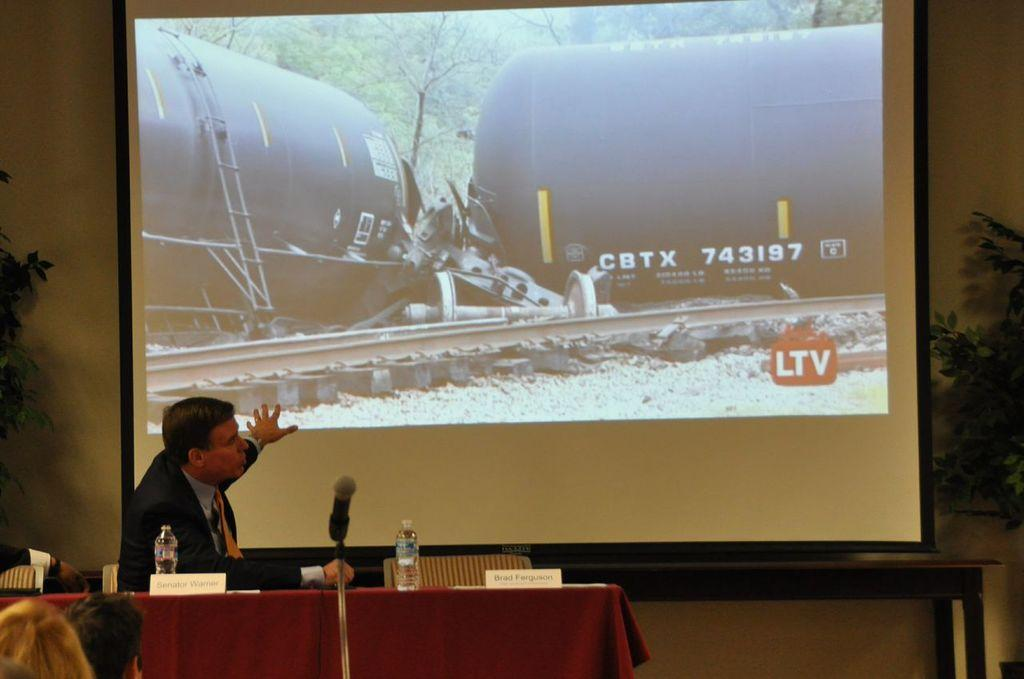<image>
Give a short and clear explanation of the subsequent image. A man talks about a tanker labeled CBTX 743197 